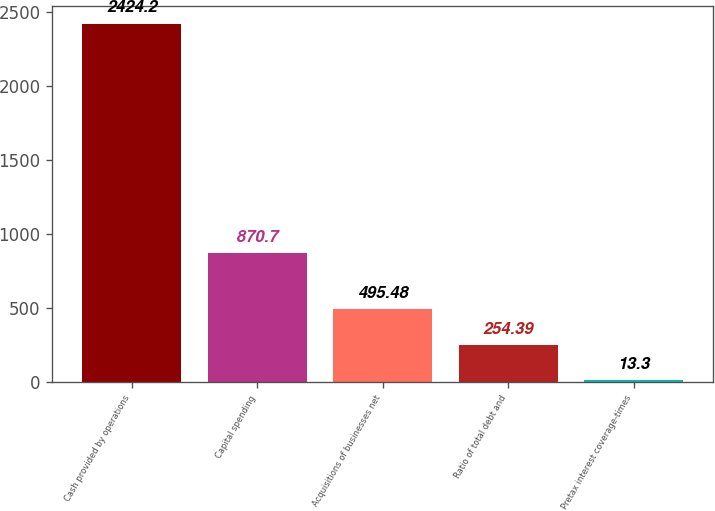Convert chart. <chart><loc_0><loc_0><loc_500><loc_500><bar_chart><fcel>Cash provided by operations<fcel>Capital spending<fcel>Acquisitions of businesses net<fcel>Ratio of total debt and<fcel>Pretax interest coverage-times<nl><fcel>2424.2<fcel>870.7<fcel>495.48<fcel>254.39<fcel>13.3<nl></chart> 